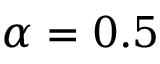<formula> <loc_0><loc_0><loc_500><loc_500>\alpha = 0 . 5</formula> 